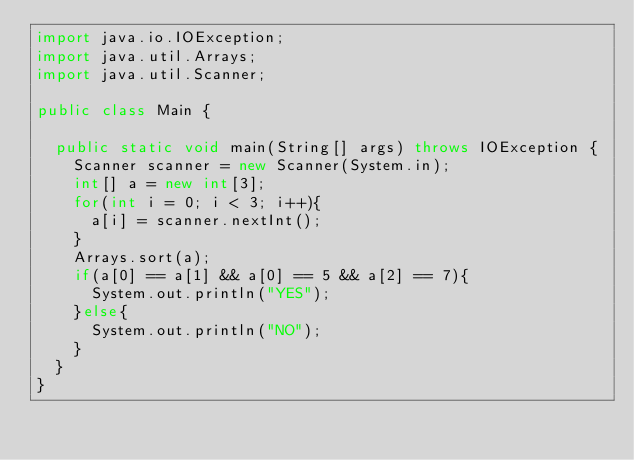<code> <loc_0><loc_0><loc_500><loc_500><_Java_>import java.io.IOException;
import java.util.Arrays;
import java.util.Scanner;

public class Main {

	public static void main(String[] args) throws IOException {
		Scanner scanner = new Scanner(System.in);
		int[] a = new int[3];
		for(int i = 0; i < 3; i++){
			a[i] = scanner.nextInt();
		}
		Arrays.sort(a);
		if(a[0] == a[1] && a[0] == 5 && a[2] == 7){
			System.out.println("YES");
		}else{
			System.out.println("NO");
		}
	}
}</code> 